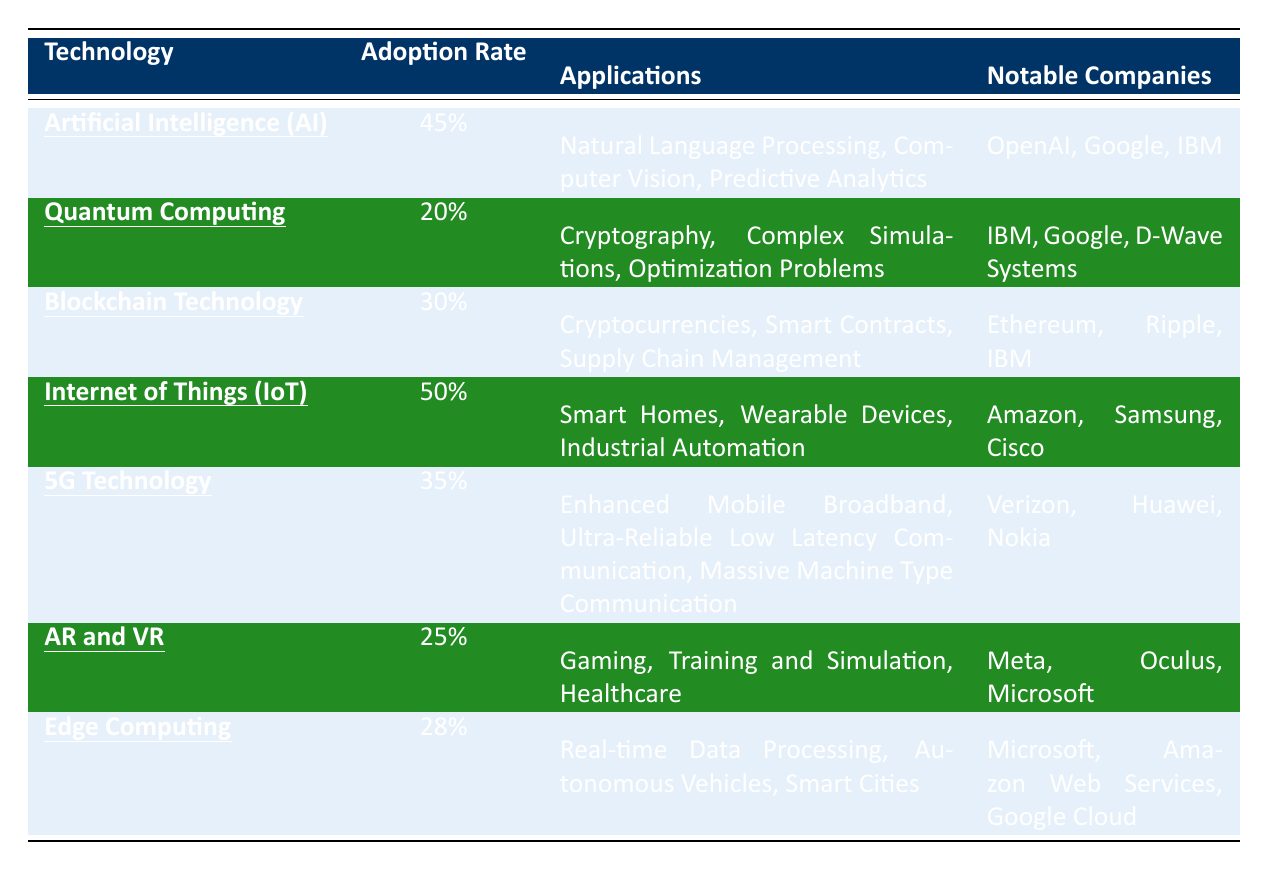What is the adoption rate of Artificial Intelligence (AI)? The adoption rate of AI is listed directly in the table. The value next to "Artificial Intelligence (AI)" under the "Adoption Rate" column is 45%.
Answer: 45% Which technology has the highest adoption rate? By comparing the values in the "Adoption Rate" column, Internet of Things (IoT) has the highest rate at 50%.
Answer: Internet of Things (IoT) Is Blockchain Technology more widely adopted than Quantum Computing? The adoption rate of Blockchain Technology is 30%, while Quantum Computing has an adoption rate of 20%. Since 30% is greater than 20%, Blockchain Technology is indeed more widely adopted.
Answer: Yes What are the notable companies associated with Edge Computing? The notable companies listed under "Edge Computing" in the table are Microsoft, Amazon Web Services, and Google Cloud.
Answer: Microsoft, Amazon Web Services, Google Cloud Calculate the average adoption rate of the technologies listed in the table. To find the average, sum the adoption rates: (45 + 20 + 30 + 50 + 35 + 25 + 28) = 233. Then divide by the number of technologies (7): 233/7 = 33.29, rounding gives an average of approximately 33%.
Answer: 33% Which technology has the least number of applications listed? The "Applications" column shows that Quantum Computing has 3 applications listed, which is the same as others except for AR and VR, which also has 3. However, both share the lowest count among all technologies.
Answer: Quantum Computing and AR and VR Is there a technology that focuses on healthcare applications? Checking the "Applications" column for each technology, Augmented Reality (AR) and Virtual Reality (VR) includes "Healthcare" as one of its applications. Thus, it does focus on healthcare.
Answer: Yes How many technologies have an adoption rate above 30%? By reviewing the adoption rates, the technologies with rates higher than 30% are AI (45%), IoT (50%), and 5G Technology (35%). Counting them gives a total of 3 technologies.
Answer: 3 What applications does the Internet of Things (IoT) cover? The table specifies that IoT applications include "Smart Homes," "Wearable Devices," and "Industrial Automation." Listing these gives the applications for IoT.
Answer: Smart Homes, Wearable Devices, Industrial Automation Which technology is associated with the company "OpenAI"? The table indicates that "OpenAI" is listed under the notable companies for Artificial Intelligence (AI). So, the association is direct and confirmed.
Answer: Artificial Intelligence (AI) Are there any technologies that focus on communication? Examining the table, 5G Technology includes applications related to communication ("Enhanced Mobile Broadband," "Ultra-Reliable Low Latency Communication," and "Massive Machine Type Communication"), thus confirming a focus on communication.
Answer: Yes 